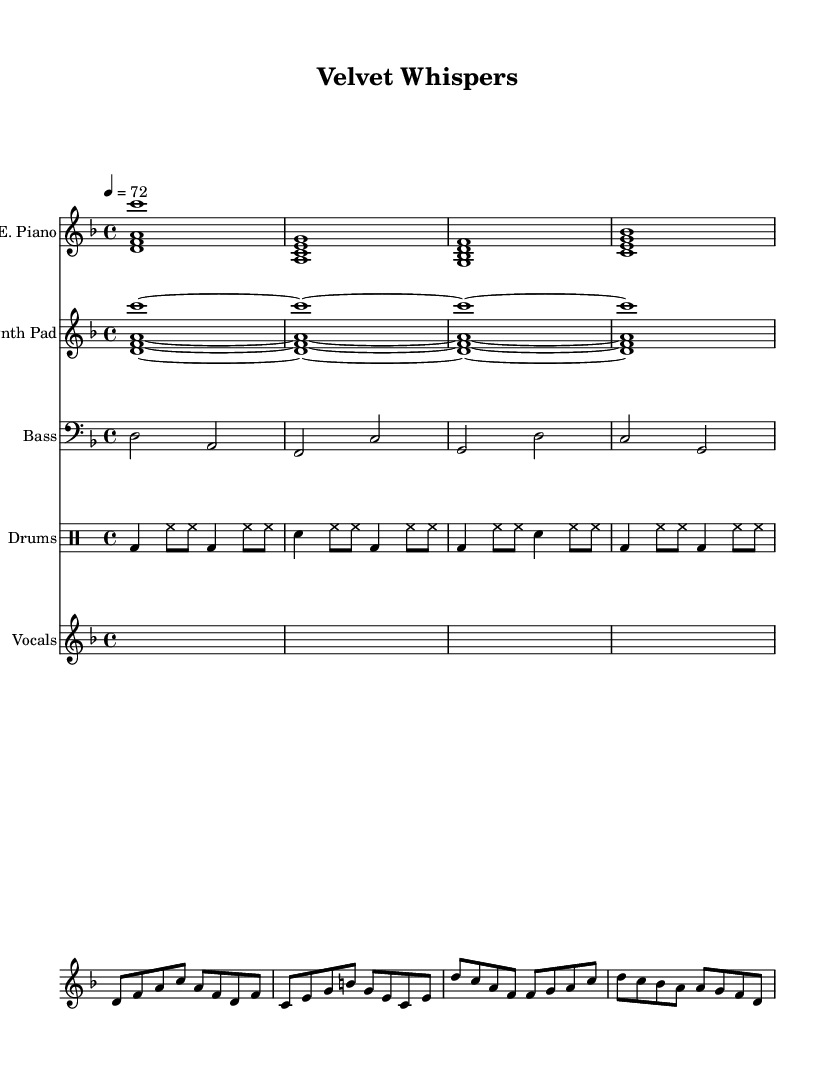What is the key signature of this music? The key signature is indicated by the presence of one flat (B flat), which corresponds to the key of D minor.
Answer: D minor What is the time signature of the piece? The time signature is indicated at the beginning of the score as 4/4, meaning there are four beats per measure.
Answer: 4/4 What is the tempo marking for this music? The tempo marking is specified as "4 = 72," indicating that there are 72 beats per minute.
Answer: 72 How many measures are in the intro? The introduction consists of 4 measures as evidenced by the grouping of notes before the verse starts.
Answer: 4 What instrument plays the bass part? The bass part is played by the bass guitar, as indicated by the staff labeled "Bass."
Answer: Bass guitar Which part is a voice with lyrics designed for this R&B piece? The lyrics are associated with the "Vocals" staff which includes a voice for singing the lyrics.
Answer: Vocals What type of rhythms are primarily used in the drum part? The drum part primarily uses a combination of bass drum and hi-hat rhythms, along with snare accents, typical for R&B styles.
Answer: Bass and hi-hat 